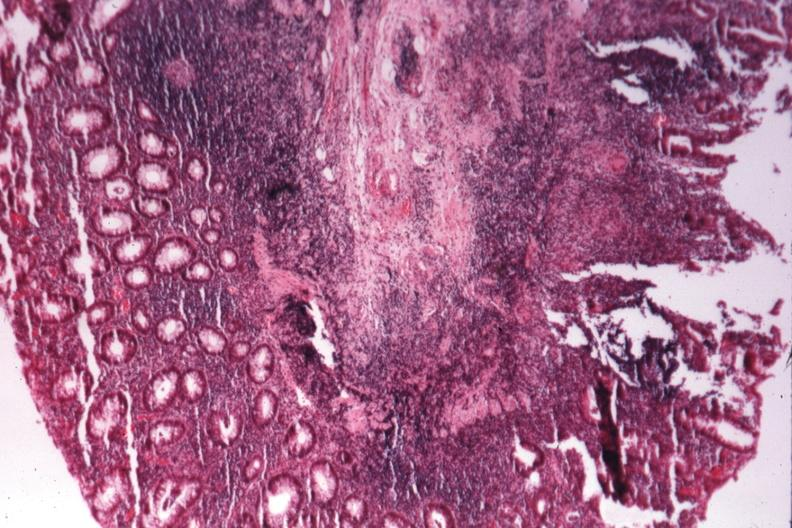s gastrointestinal present?
Answer the question using a single word or phrase. Yes 